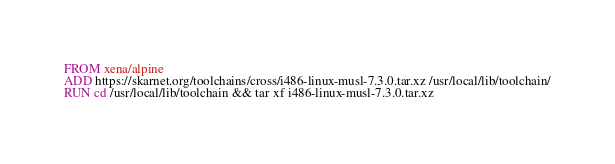<code> <loc_0><loc_0><loc_500><loc_500><_Dockerfile_>FROM xena/alpine
ADD https://skarnet.org/toolchains/cross/i486-linux-musl-7.3.0.tar.xz /usr/local/lib/toolchain/
RUN cd /usr/local/lib/toolchain && tar xf i486-linux-musl-7.3.0.tar.xz </code> 